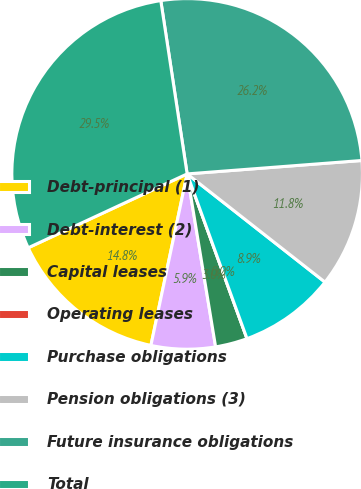Convert chart to OTSL. <chart><loc_0><loc_0><loc_500><loc_500><pie_chart><fcel>Debt-principal (1)<fcel>Debt-interest (2)<fcel>Capital leases<fcel>Operating leases<fcel>Purchase obligations<fcel>Pension obligations (3)<fcel>Future insurance obligations<fcel>Total<nl><fcel>14.76%<fcel>5.91%<fcel>2.95%<fcel>0.0%<fcel>8.86%<fcel>11.81%<fcel>26.18%<fcel>29.52%<nl></chart> 